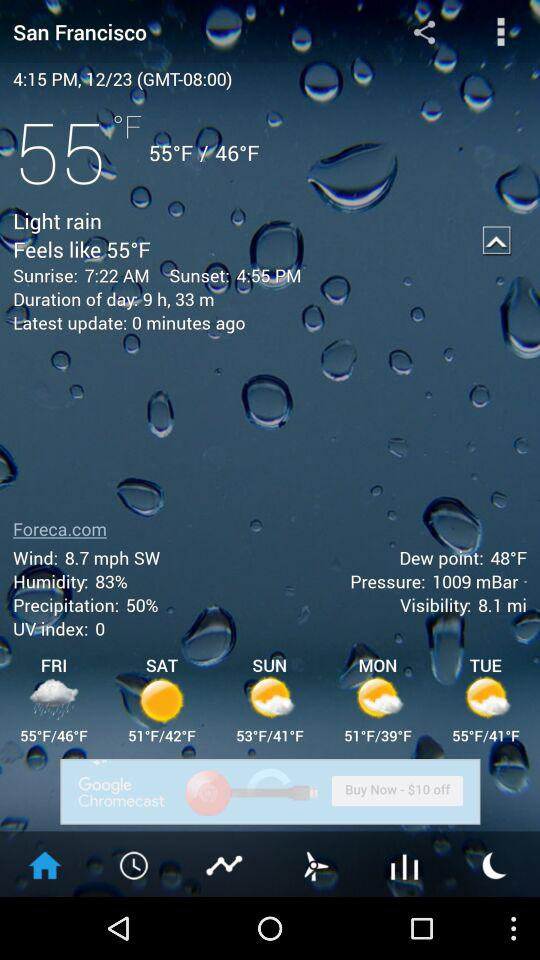What is the location? The location is San Francisco. 